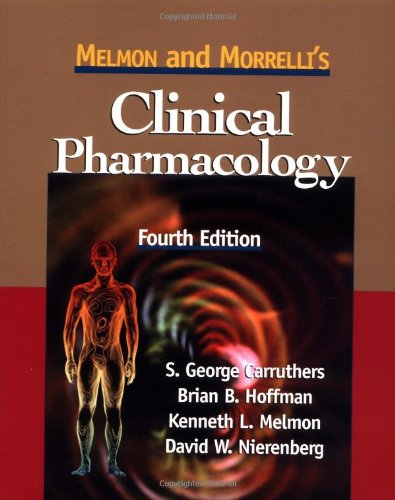What is the title of this book? The title of the book featured in the image is 'Melmon and Morrelli's Clinical Pharmacology,' specifically its fourth edition. 